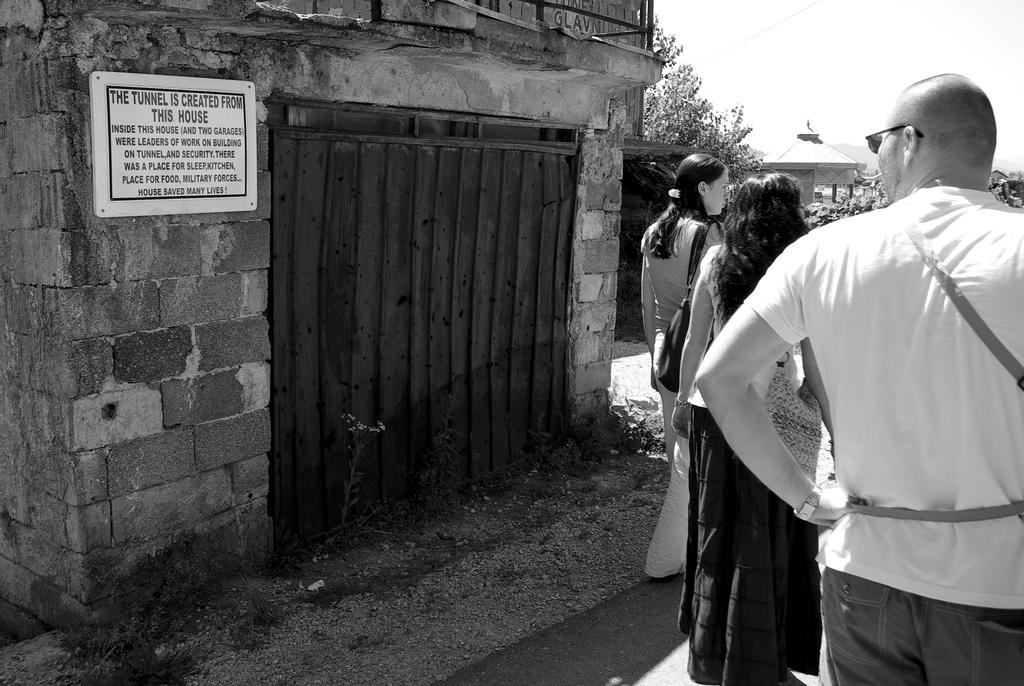What is the color scheme of the image? The image is black and white. What can be seen on the brick wall in the image? There is a board on a brick wall in the image. Are there any people present in the image? Yes, there are people visible in the image. What type of statement is being made by the scissors in the image? There are no scissors present in the image, so it is not possible to determine what statement they might be making. 